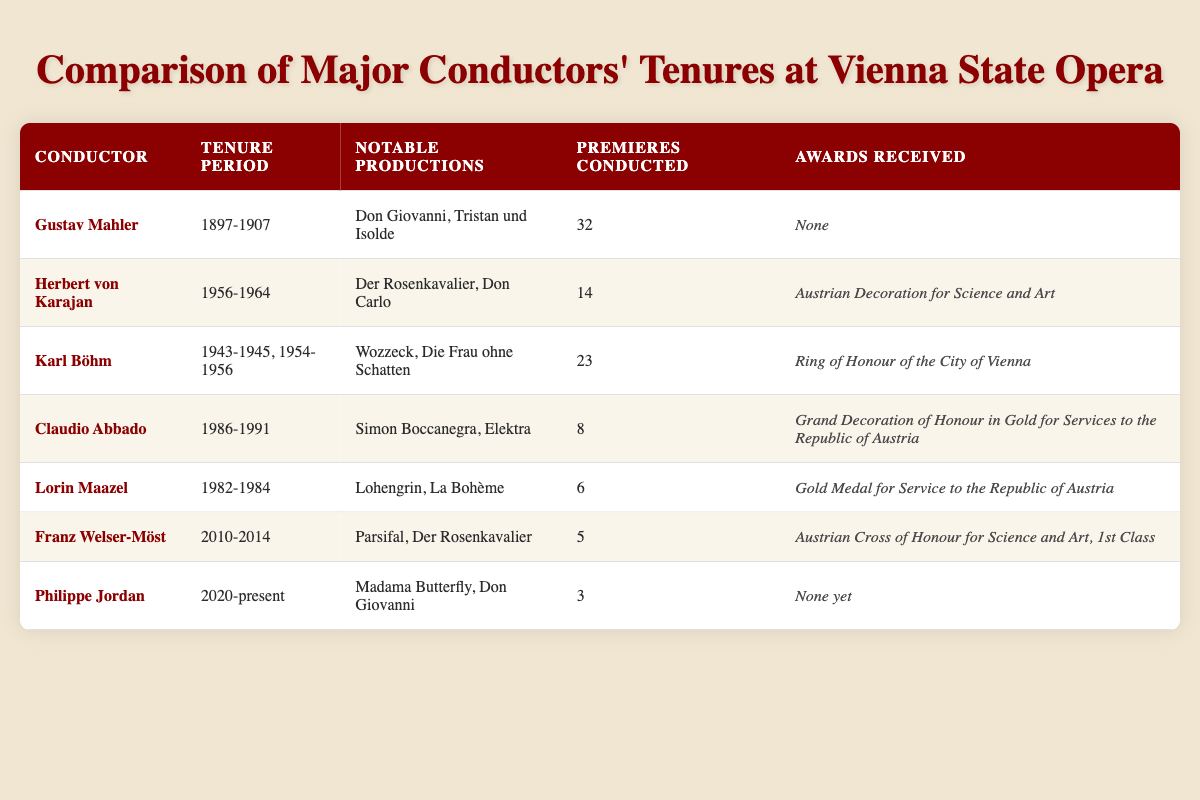What is the tenure period of Claudio Abbado? The table lists Claudio Abbado's tenure period as "1986-1991."
Answer: 1986-1991 How many premieres did Herbert von Karajan conduct? According to the table, Herbert von Karajan conducted 14 premieres.
Answer: 14 Did Gustav Mahler receive any awards during his tenure? The table states that Gustav Mahler received "None" in terms of awards.
Answer: No Which conductor had the longest tenure at Vienna State Opera? By examining the tenure periods, Gustav Mahler (1897-1907) had a total of 10 years, which is the longest among the listed conductors.
Answer: Gustav Mahler What is the average number of premieres conducted by the conductors listed in the table? The total number of premieres is 32 (Mahler) + 14 (Karajan) + 23 (Böhm) + 8 (Abbado) + 6 (Maazel) + 5 (Welser-Möst) + 3 (Jordan) = 91. There are 7 conductors, so the average is 91/7 ≈ 13.
Answer: 13 How many awards did Franz Welser-Möst receive during his tenure? According to the table, Franz Welser-Möst received the "Austrian Cross of Honour for Science and Art, 1st Class."
Answer: Austrian Cross of Honour for Science and Art, 1st Class Is it true that Philippe Jordan has conducted more premieres than Lorin Maazel? Philippe Jordan conducted 3 premieres, while Lorin Maazel conducted 6. Since 3 is less than 6, the statement is false.
Answer: No Which notable production did both Herbert von Karajan and Franz Welser-Möst conduct? Both conductors had "Der Rosenkavalier" listed as one of their notable productions in the table, indicating a shared involvement with the opera.
Answer: Der Rosenkavalier What is the difference in the number of premieres conducted between Herbert von Karajan and Karl Böhm? Herbert von Karajan conducted 14 premieres, while Karl Böhm conducted 23. The difference is 23 - 14 = 9.
Answer: 9 Which conductors had their tenure during the second half of the 20th century? The table shows that Herbert von Karajan (1956-1964), Karl Böhm (1943-1945, 1954-1956), Claudio Abbado (1986-1991), and Lorin Maazel (1982-1984) all had tenures in the second half of the 20th century.
Answer: Herbert von Karajan, Karl Böhm, Claudio Abbado, Lorin Maazel 